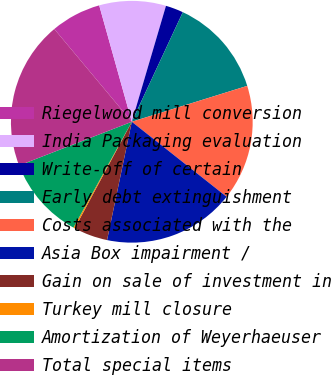<chart> <loc_0><loc_0><loc_500><loc_500><pie_chart><fcel>Riegelwood mill conversion<fcel>India Packaging evaluation<fcel>Write-off of certain<fcel>Early debt extinguishment<fcel>Costs associated with the<fcel>Asia Box impairment /<fcel>Gain on sale of investment in<fcel>Turkey mill closure<fcel>Amortization of Weyerhaeuser<fcel>Total special items<nl><fcel>6.73%<fcel>8.91%<fcel>2.37%<fcel>13.27%<fcel>15.45%<fcel>17.63%<fcel>4.55%<fcel>0.19%<fcel>11.09%<fcel>19.81%<nl></chart> 